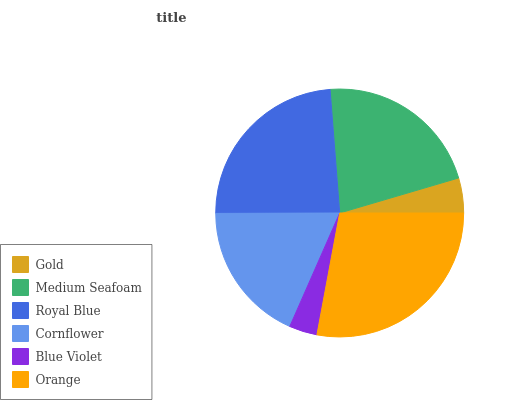Is Blue Violet the minimum?
Answer yes or no. Yes. Is Orange the maximum?
Answer yes or no. Yes. Is Medium Seafoam the minimum?
Answer yes or no. No. Is Medium Seafoam the maximum?
Answer yes or no. No. Is Medium Seafoam greater than Gold?
Answer yes or no. Yes. Is Gold less than Medium Seafoam?
Answer yes or no. Yes. Is Gold greater than Medium Seafoam?
Answer yes or no. No. Is Medium Seafoam less than Gold?
Answer yes or no. No. Is Medium Seafoam the high median?
Answer yes or no. Yes. Is Cornflower the low median?
Answer yes or no. Yes. Is Orange the high median?
Answer yes or no. No. Is Gold the low median?
Answer yes or no. No. 